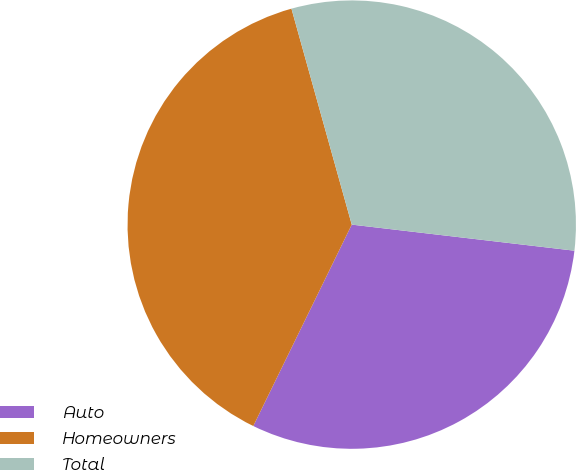<chart> <loc_0><loc_0><loc_500><loc_500><pie_chart><fcel>Auto<fcel>Homeowners<fcel>Total<nl><fcel>30.38%<fcel>38.43%<fcel>31.19%<nl></chart> 